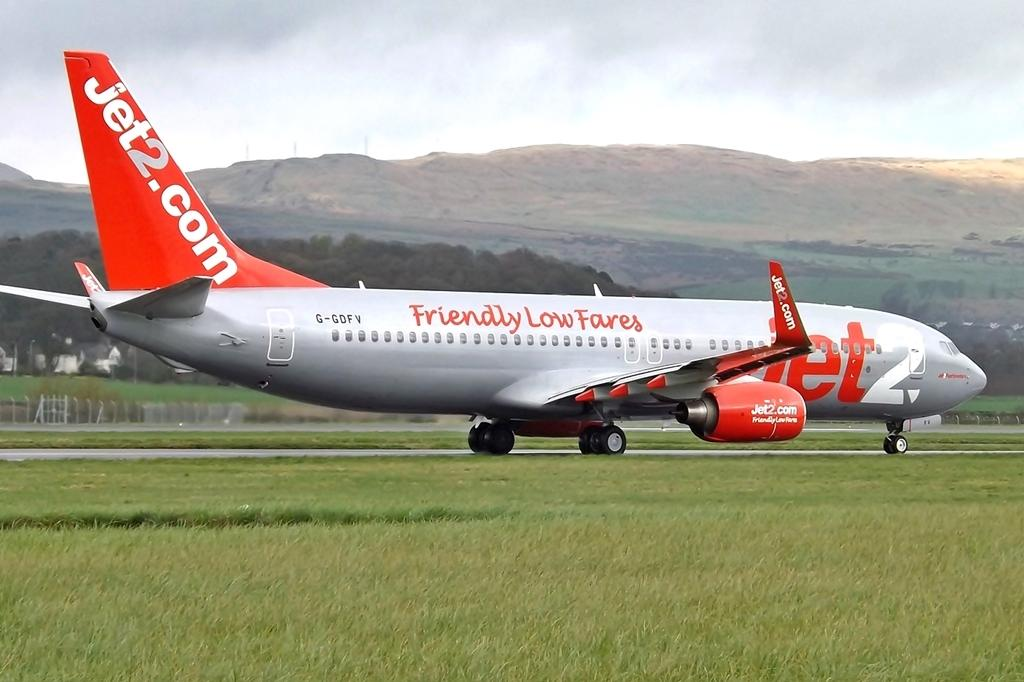Provide a one-sentence caption for the provided image. the plane says friendly low fares is a Jet airlines plane. 